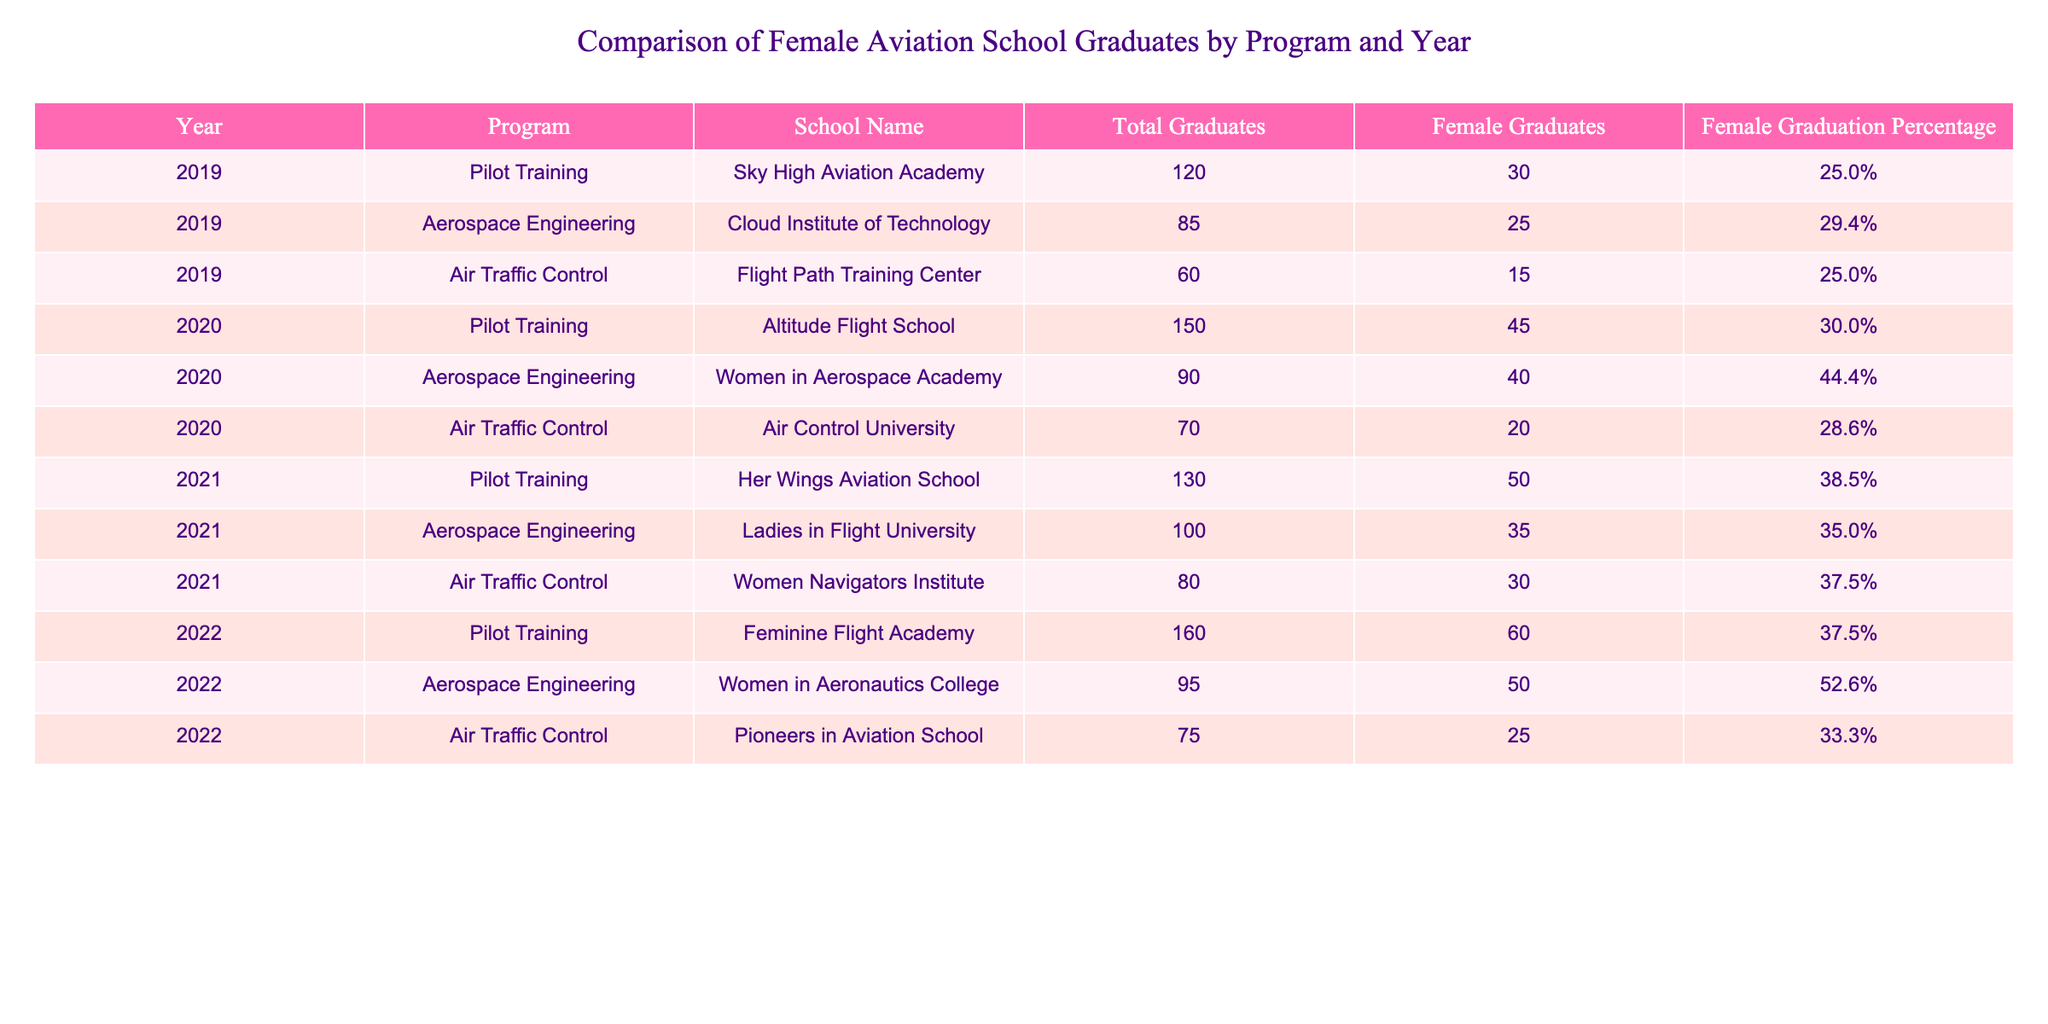What is the total number of female graduates in 2020? In 2020, we look at the 'Female Graduates' column specifically for that year. The relevant rows show 45 graduates from Pilot Training, 40 from Aerospace Engineering, and 20 from Air Traffic Control. Adding these together: 45 + 40 + 20 = 105.
Answer: 105 Which program had the highest female graduation percentage in 2022? For 2022, we evaluate the 'Female Graduation Percentage' for each program. Pilot Training has 37.5%, Aerospace Engineering has 52.6%, and Air Traffic Control has 33.3%. The highest is 52.6%, which corresponds to Aerospace Engineering.
Answer: Aerospace Engineering Is the statement "The number of female graduates increased every year" true? To verify this, we can check the total number of female graduates for each year. In 2019, there were 30; in 2020, there were 45; in 2021, there were 50; and in 2022, there were 60. The number did increase each year, hence the statement is true.
Answer: Yes What is the average percentage of female graduates across all programs in 2021? First, we need to sum the female graduation percentages for 2021: Pilot Training 38.5%, Aerospace Engineering 35.0%, and Air Traffic Control 37.5%. Adding these gives a total of 38.5 + 35.0 + 37.5 = 111.0. There are three programs, so we divide by 3: 111.0 / 3 = 37.0.
Answer: 37.0 Which school had the lowest total number of female graduates in 2019? Looking at the 'Total Graduates' and 'Female Graduates' columns for 2019, we see: Sky High Aviation Academy with 30, Cloud Institute of Technology with 25, and Flight Path Training Center with 15. The lowest number of female graduates is 15 from Flight Path Training Center.
Answer: Flight Path Training Center 